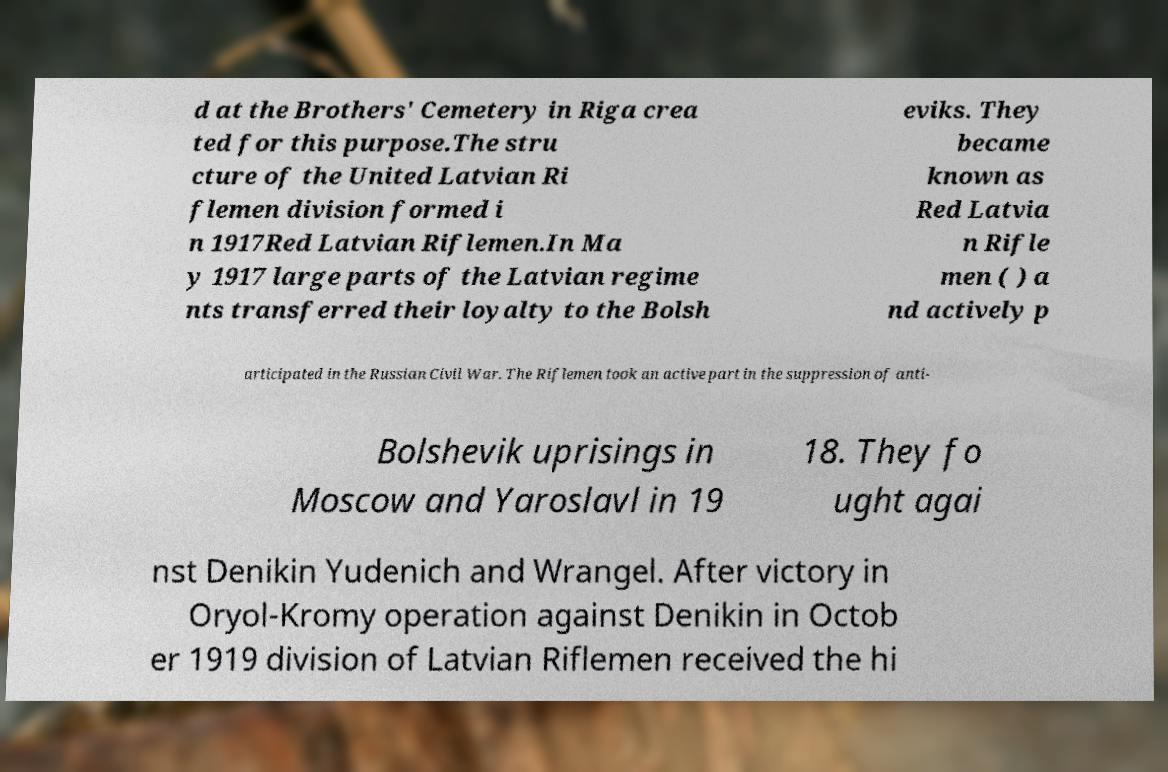Can you accurately transcribe the text from the provided image for me? d at the Brothers' Cemetery in Riga crea ted for this purpose.The stru cture of the United Latvian Ri flemen division formed i n 1917Red Latvian Riflemen.In Ma y 1917 large parts of the Latvian regime nts transferred their loyalty to the Bolsh eviks. They became known as Red Latvia n Rifle men ( ) a nd actively p articipated in the Russian Civil War. The Riflemen took an active part in the suppression of anti- Bolshevik uprisings in Moscow and Yaroslavl in 19 18. They fo ught agai nst Denikin Yudenich and Wrangel. After victory in Oryol-Kromy operation against Denikin in Octob er 1919 division of Latvian Riflemen received the hi 